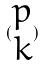Convert formula to latex. <formula><loc_0><loc_0><loc_500><loc_500>( \begin{matrix} p \\ k \end{matrix} )</formula> 